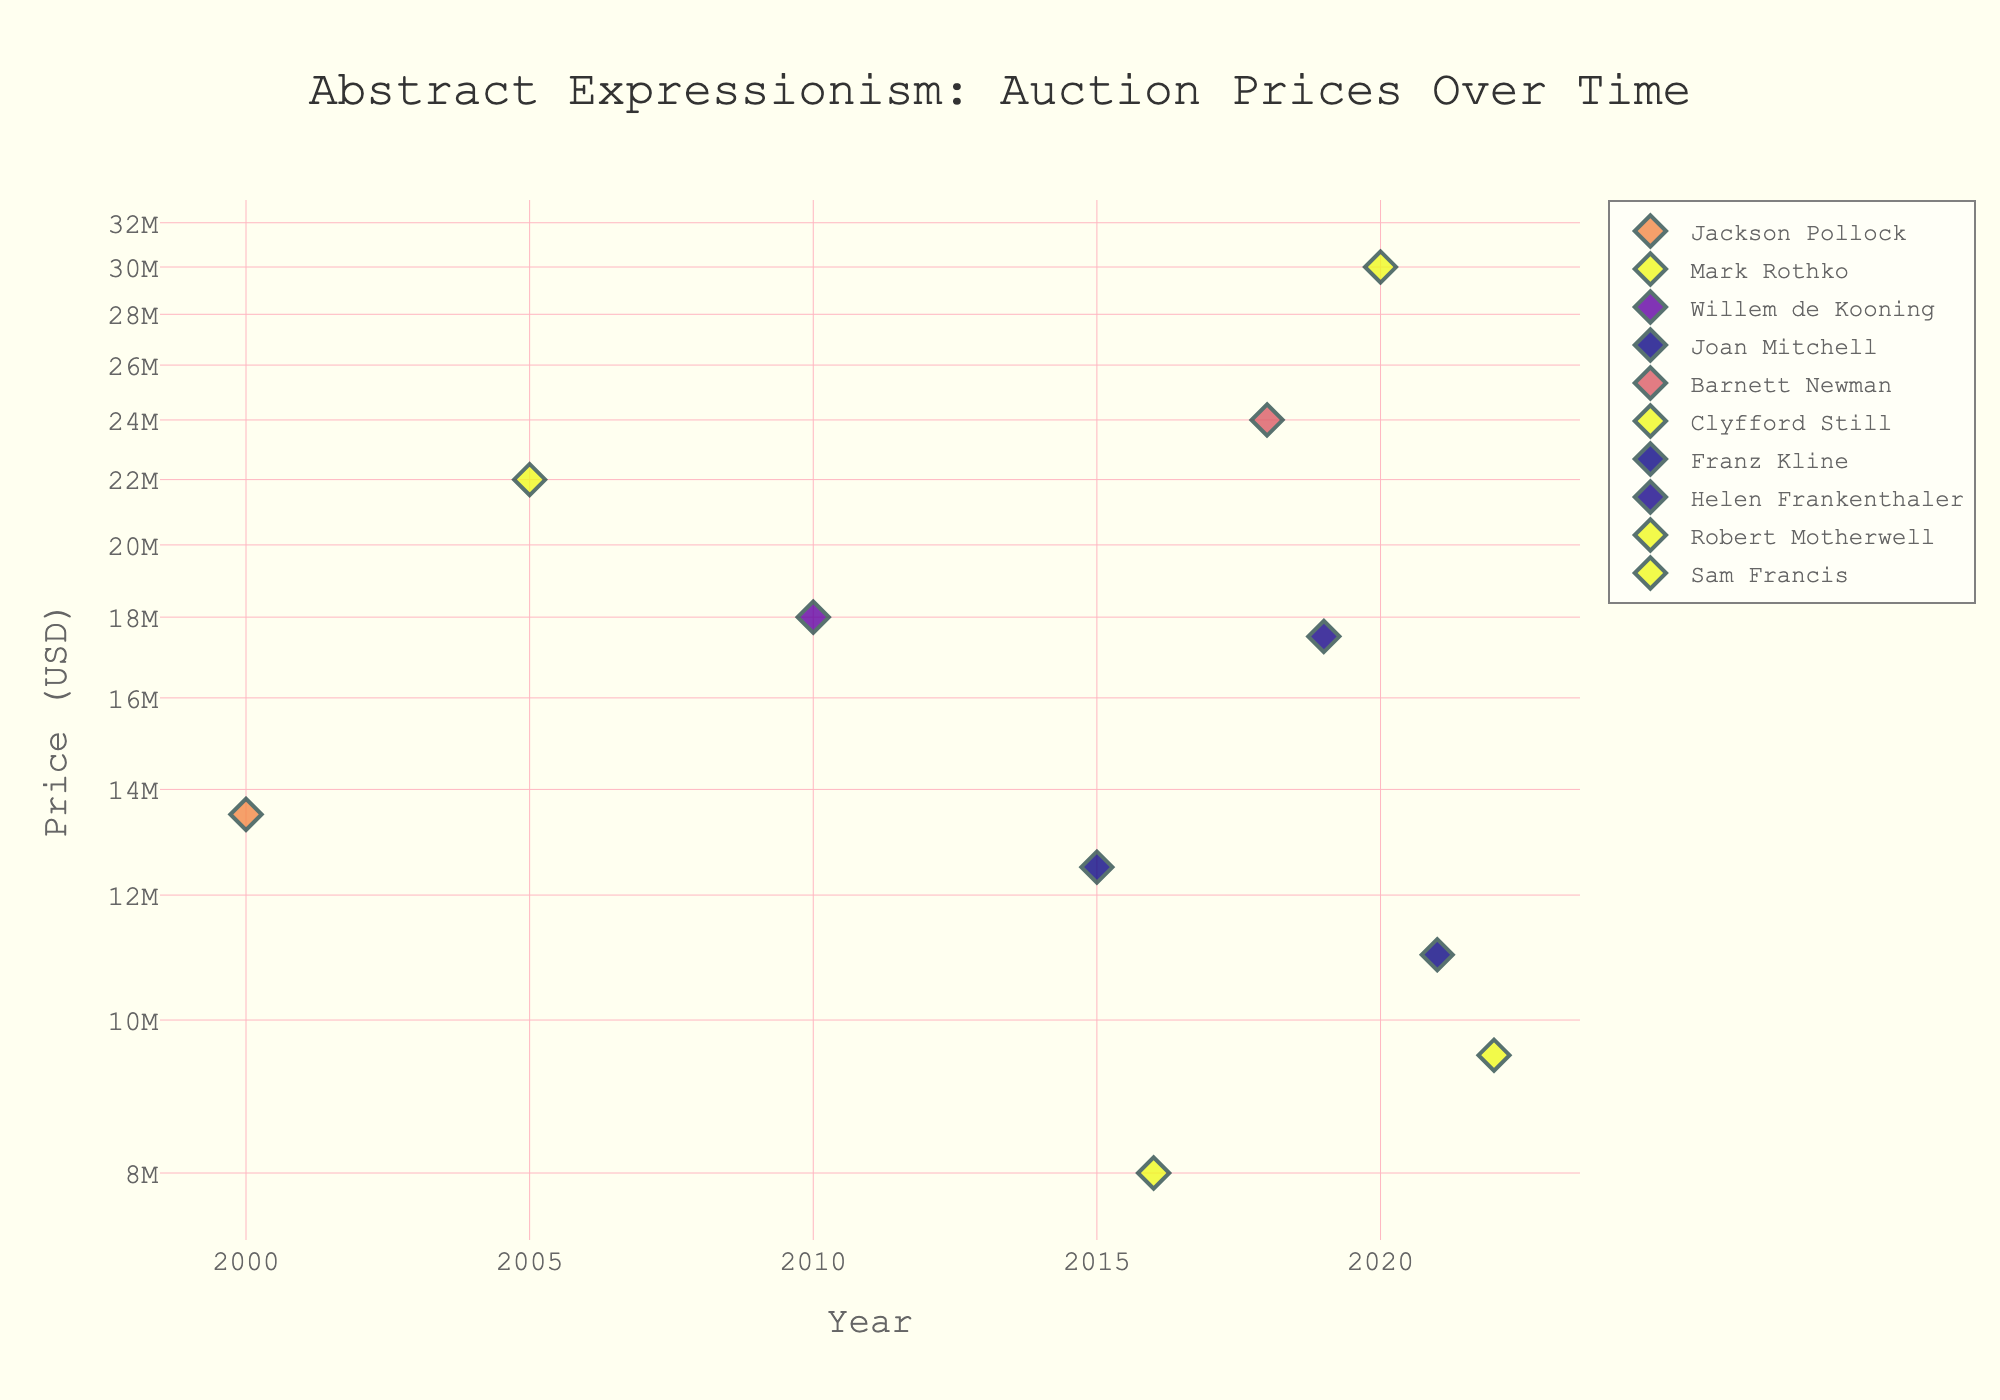What is the title of the scatter plot? The title is usually placed at the top of the plot and provides a summary of what the scatter plot represents.
Answer: Abstract Expressionism: Auction Prices Over Time Which artist has the highest auction price, and what is that price? Identify the highest data point on the y-axis and find the corresponding artist label.
Answer: Clyfford Still, $30,000,000 How many artists have auction prices above $20,000,000? Look at the y-axis and count the number of unique markers above the $20,000,000 mark.
Answer: 3 artists In what year did Barnett Newman’s artwork fetch an auction price, and what was that price? Locate Barnett Newman's marker on the plot and note the x (year) and y (price) coordinates.
Answer: 2018, $24,000,000 What is the price range of the abstract expressionist artworks in the scatter plot? Identify the minimum and maximum y-axis values showing the range of prices.
Answer: $8,000,000 to $30,000,000 How does Mark Rothko’s auction price compare to Sam Francis's? Find and compare the markers corresponding to Mark Rothko and Sam Francis. Rothko's price is $22,000,000 and Francis's is $8,000,000. Rothko's price is higher.
Answer: Mark Rothko's price is higher What is the average auction price of artworks sold in Christie's? First, identify all artworks sold in Christie's, sum up their prices, and then divide by the number of artworks. Prices at Christie's: $13,500,000 (Pollock) + $12,500,000 (Mitchell) + $11,000,000 (Kline) + $8,000,000 (Francis) = $45,000,000. There are 4 artworks, so average price = $45,000,000 / 4.
Answer: $11,250,000 Which auction house hosted the sale of the most expensive artwork? Locate the highest data point and note the corresponding auction house.
Answer: Phillips In which year was the lowest auction price recorded, and which artist does it belong to? Identify the lowest point on the y-axis and check its x-axis value and artist label.
Answer: 2022, Robert Motherwell Is the auction price trend for Jackson Pollock increasing or decreasing over the years according to the scatter plot? Locate data points for Jackson Pollock and observe the direction of his auction prices over the years. Since there is only one data point, it's insufficient to determine a trend.
Answer: Insufficient data 